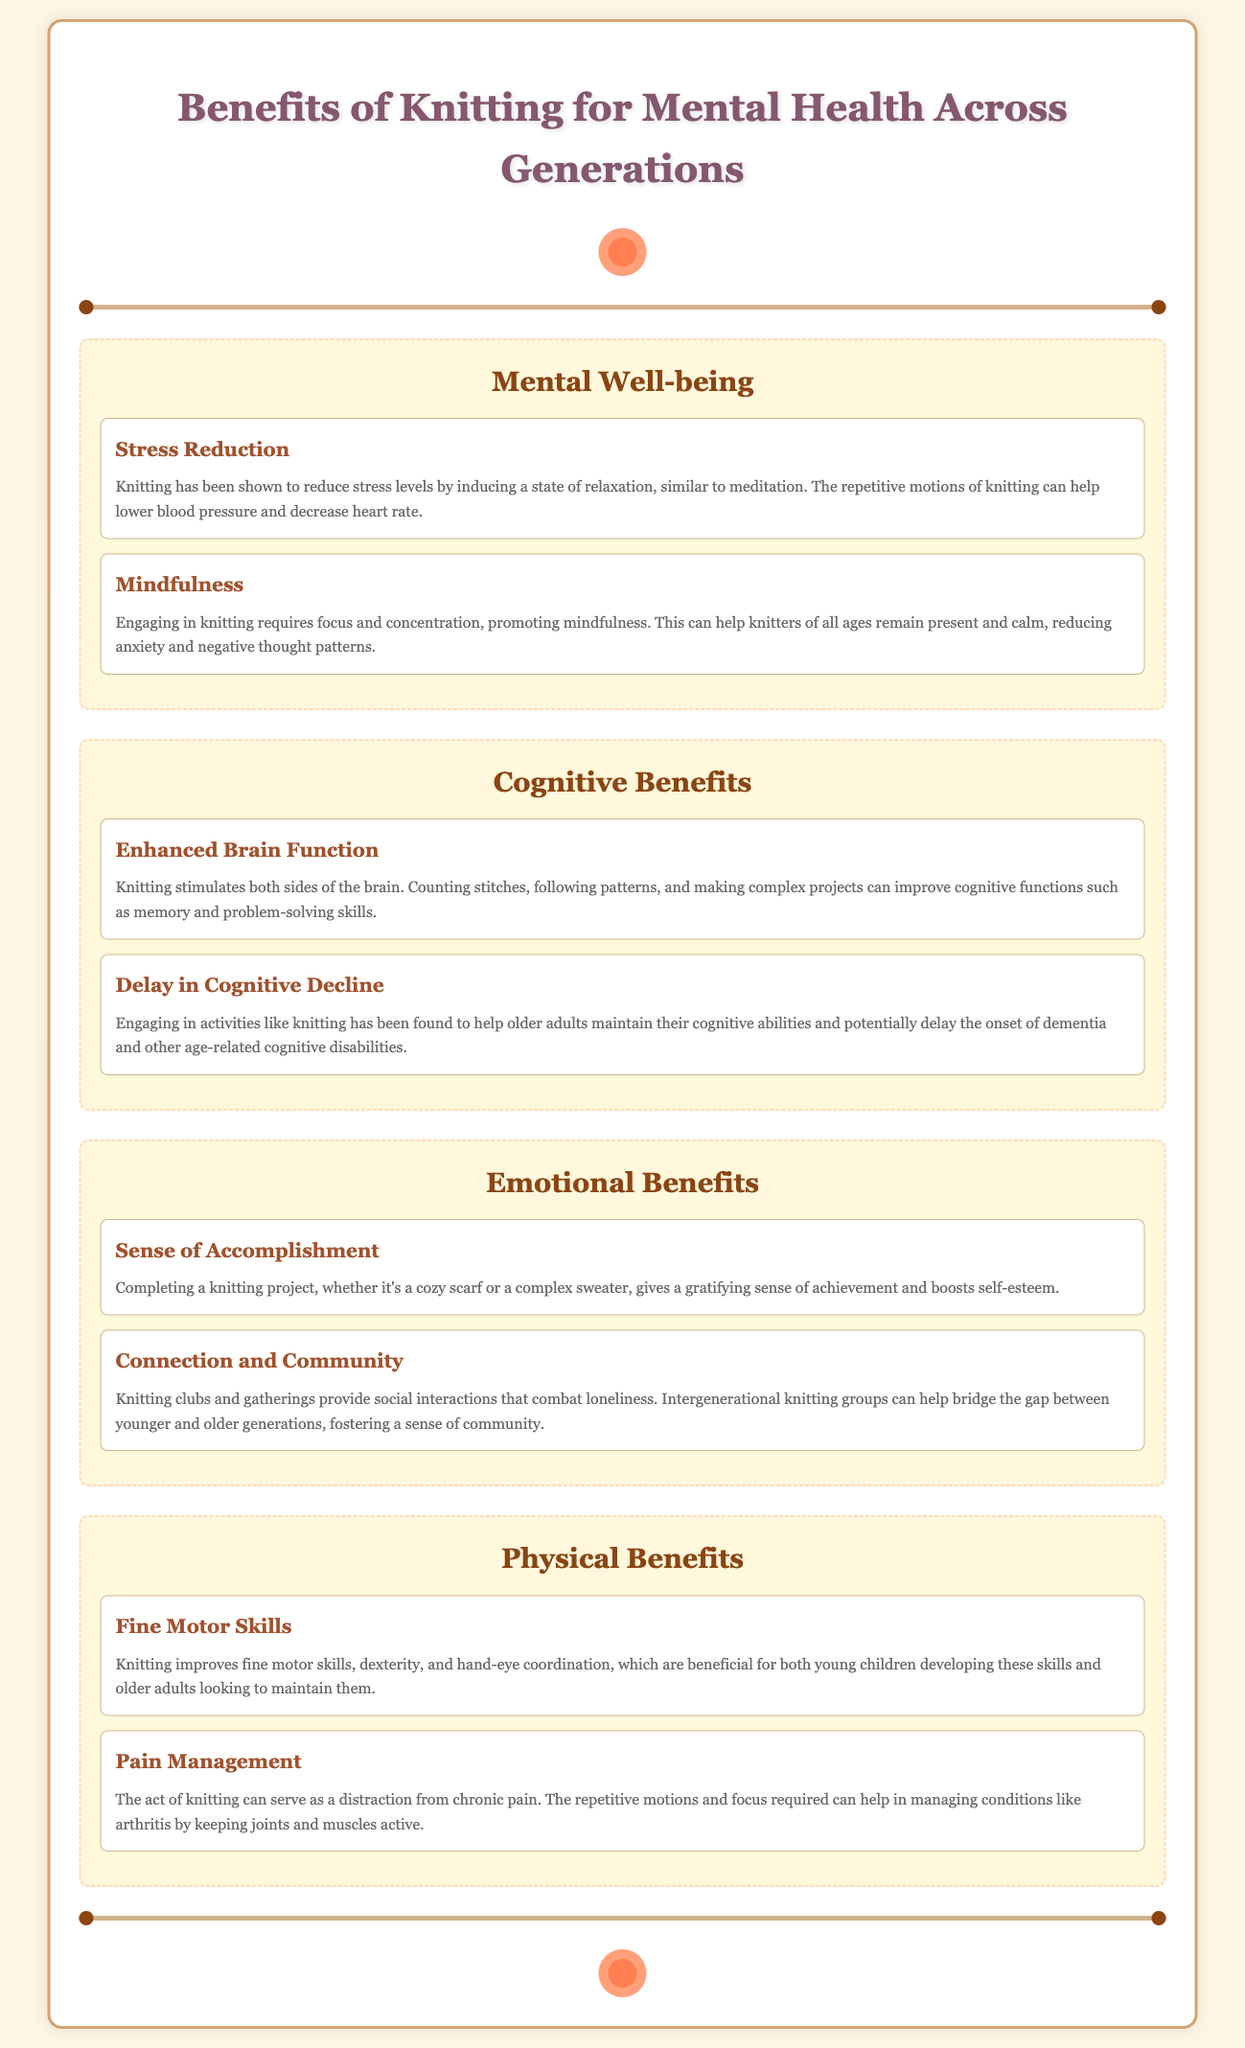What is the title of the infographic? The title of the infographic is displayed prominently at the top of the document, stating the main topic.
Answer: Benefits of Knitting for Mental Health Across Generations How many categories are listed in the document? The document organizes the information into four distinct categories related to the benefits of knitting.
Answer: Four What is one of the benefits under Mental Well-being? The benefit listed under the Mental Well-being category focuses on reducing stress through knitting activities.
Answer: Stress Reduction Which benefit addresses cognitive decline? This benefit highlights the potential of knitting to help with cognitive issues in older adults, particularly in delaying decline.
Answer: Delay in Cognitive Decline What is a physical benefit mentioned in the infographic? The infographic lists specific physical benefits related to knitting, one being the improvement of fine motor skills.
Answer: Fine Motor Skills Why might knitting promote connection and community? Knitting brings people together through clubs and intergenerational groups, fostering social interactions.
Answer: Social interactions What type of benefit is "Mindfulness"? This question pertains to how mindfulness fits into categories, and specifically identifies it as a type of mental well-being benefit.
Answer: Mental well-being What is the primary purpose of the document? The document aims to provide information on the mental health benefits associated with knitting across different age groups.
Answer: Mental health benefits Which demographic could benefit from improved fine motor skills through knitting? This question relates to specific groups identified for improvement in motor skills from knitting.
Answer: Young children and older adults 